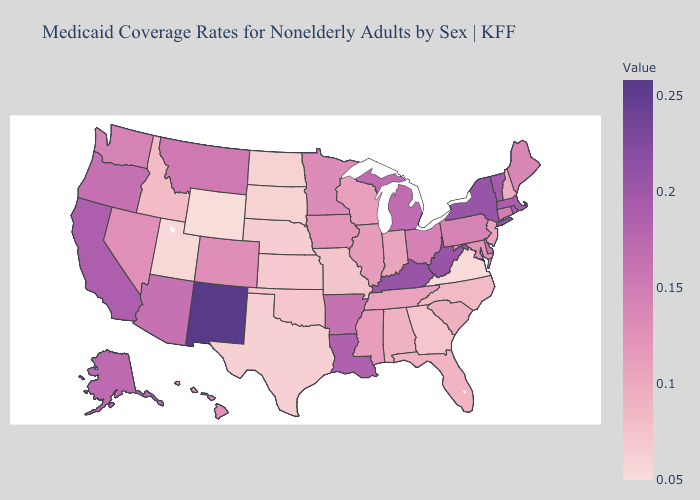Does Rhode Island have a lower value than New Mexico?
Concise answer only. Yes. Is the legend a continuous bar?
Short answer required. Yes. Which states hav the highest value in the West?
Be succinct. New Mexico. Does Wyoming have the lowest value in the USA?
Keep it brief. Yes. Among the states that border Mississippi , does Alabama have the lowest value?
Keep it brief. Yes. 